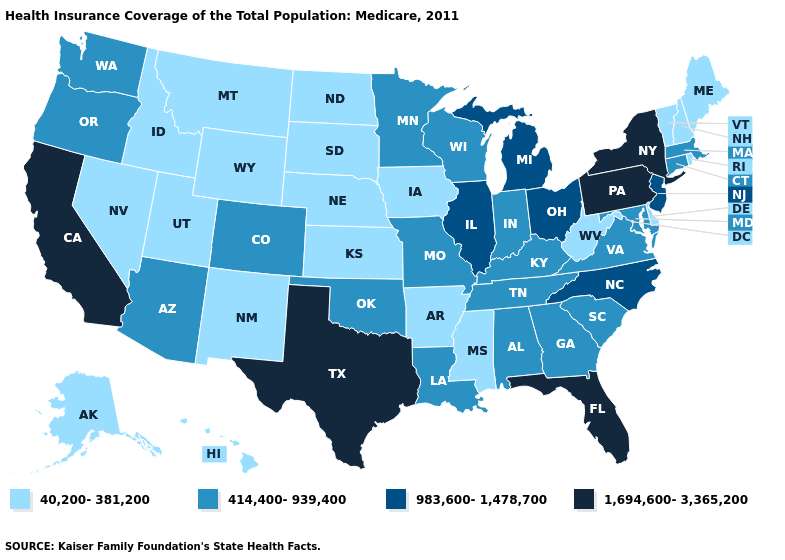Among the states that border Kansas , which have the lowest value?
Short answer required. Nebraska. How many symbols are there in the legend?
Keep it brief. 4. Among the states that border Kentucky , does Illinois have the lowest value?
Quick response, please. No. Does California have a higher value than New York?
Keep it brief. No. Does Massachusetts have the highest value in the USA?
Quick response, please. No. What is the value of Alaska?
Short answer required. 40,200-381,200. How many symbols are there in the legend?
Be succinct. 4. Name the states that have a value in the range 1,694,600-3,365,200?
Concise answer only. California, Florida, New York, Pennsylvania, Texas. Which states have the lowest value in the USA?
Concise answer only. Alaska, Arkansas, Delaware, Hawaii, Idaho, Iowa, Kansas, Maine, Mississippi, Montana, Nebraska, Nevada, New Hampshire, New Mexico, North Dakota, Rhode Island, South Dakota, Utah, Vermont, West Virginia, Wyoming. What is the value of Delaware?
Be succinct. 40,200-381,200. Which states have the lowest value in the South?
Answer briefly. Arkansas, Delaware, Mississippi, West Virginia. Does Wyoming have the highest value in the USA?
Concise answer only. No. Does Vermont have the lowest value in the USA?
Answer briefly. Yes. Which states have the lowest value in the MidWest?
Answer briefly. Iowa, Kansas, Nebraska, North Dakota, South Dakota. What is the value of Florida?
Write a very short answer. 1,694,600-3,365,200. 